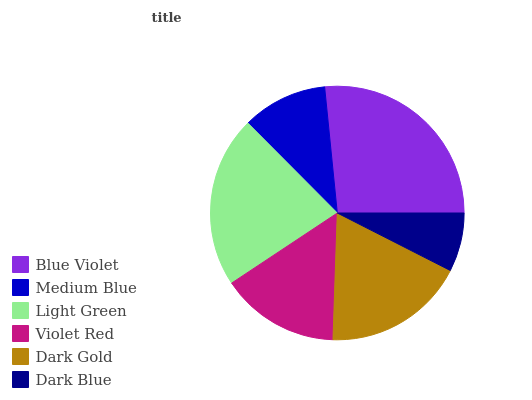Is Dark Blue the minimum?
Answer yes or no. Yes. Is Blue Violet the maximum?
Answer yes or no. Yes. Is Medium Blue the minimum?
Answer yes or no. No. Is Medium Blue the maximum?
Answer yes or no. No. Is Blue Violet greater than Medium Blue?
Answer yes or no. Yes. Is Medium Blue less than Blue Violet?
Answer yes or no. Yes. Is Medium Blue greater than Blue Violet?
Answer yes or no. No. Is Blue Violet less than Medium Blue?
Answer yes or no. No. Is Dark Gold the high median?
Answer yes or no. Yes. Is Violet Red the low median?
Answer yes or no. Yes. Is Medium Blue the high median?
Answer yes or no. No. Is Dark Blue the low median?
Answer yes or no. No. 